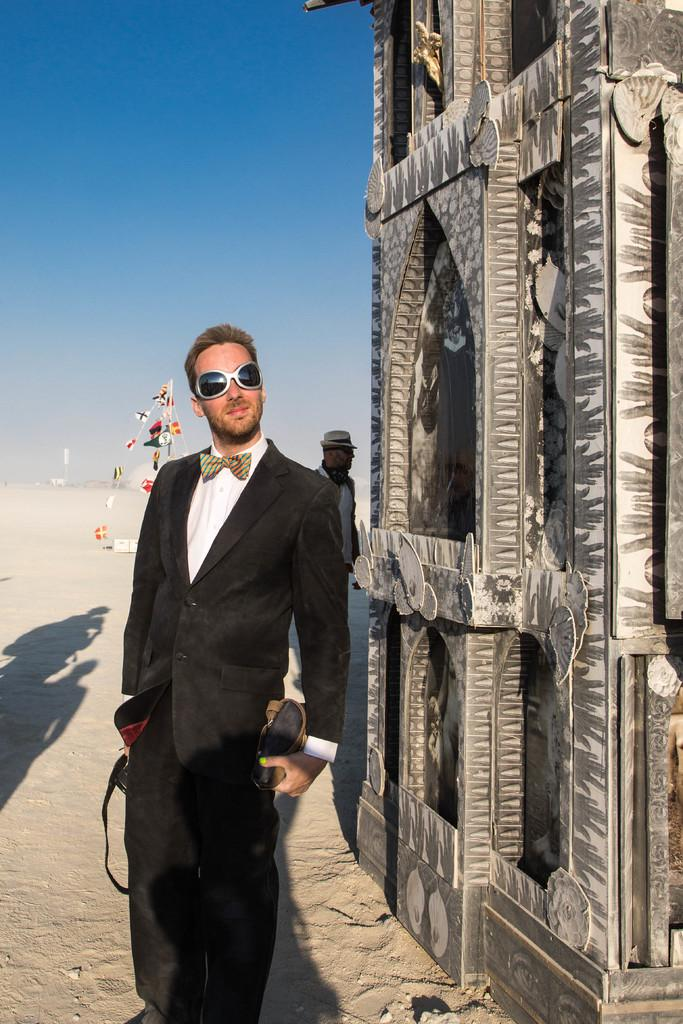How many people are in the image? There are people in the image, but the exact number is not specified. What is in the background of the image? There is a wall in the image, which is in the background. What else can be seen in the image besides people and a wall? There are objects in the image. What color is the sky in the image? The sky is blue in the image. What is the person in the front of the image holding? A person is holding objects in the front of the image. What type of protective eyewear is the person wearing? The person is wearing goggles. Where is the drawer located in the image? There is no drawer present in the image. What type of cloth is draped over the objects in the image? There is no cloth draped over the objects in the image. 